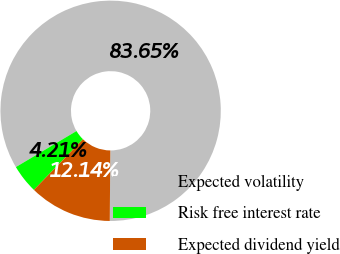Convert chart to OTSL. <chart><loc_0><loc_0><loc_500><loc_500><pie_chart><fcel>Expected volatility<fcel>Risk free interest rate<fcel>Expected dividend yield<nl><fcel>83.65%<fcel>4.21%<fcel>12.14%<nl></chart> 